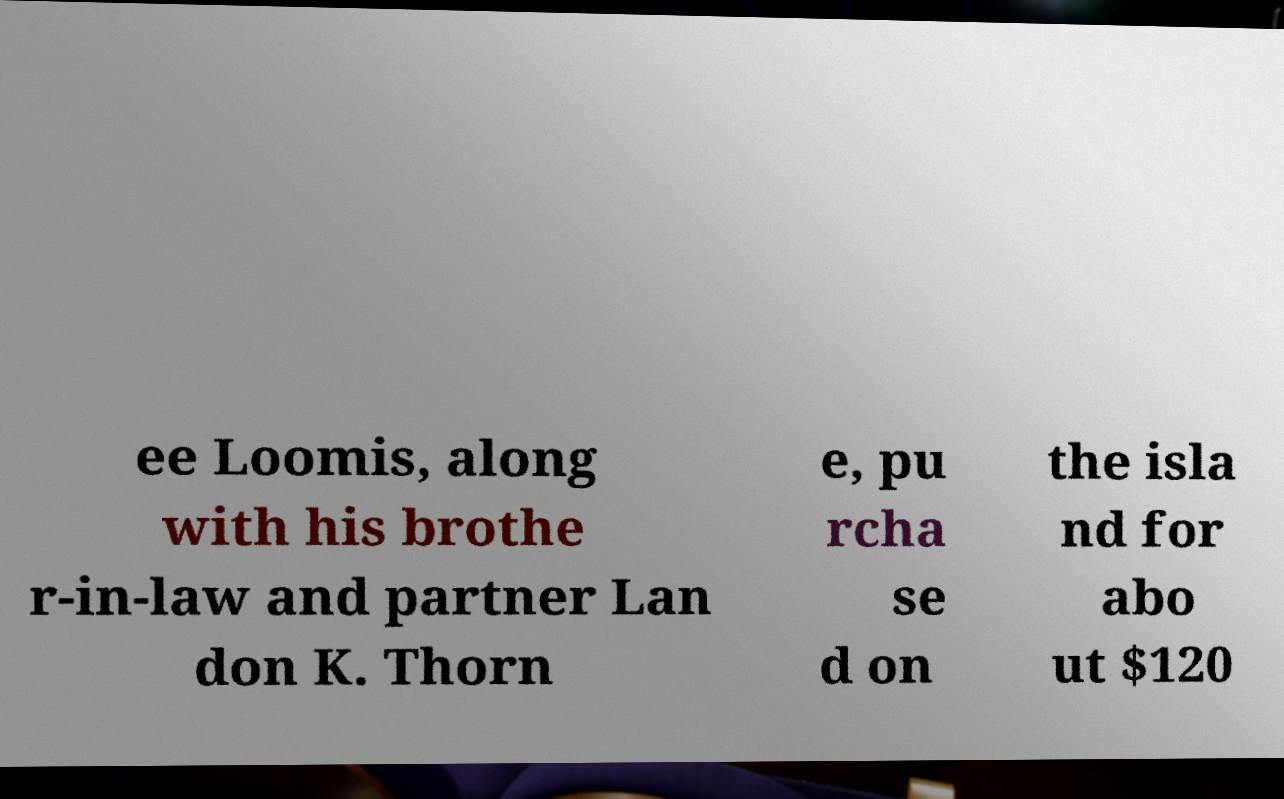Can you accurately transcribe the text from the provided image for me? ee Loomis, along with his brothe r-in-law and partner Lan don K. Thorn e, pu rcha se d on the isla nd for abo ut $120 